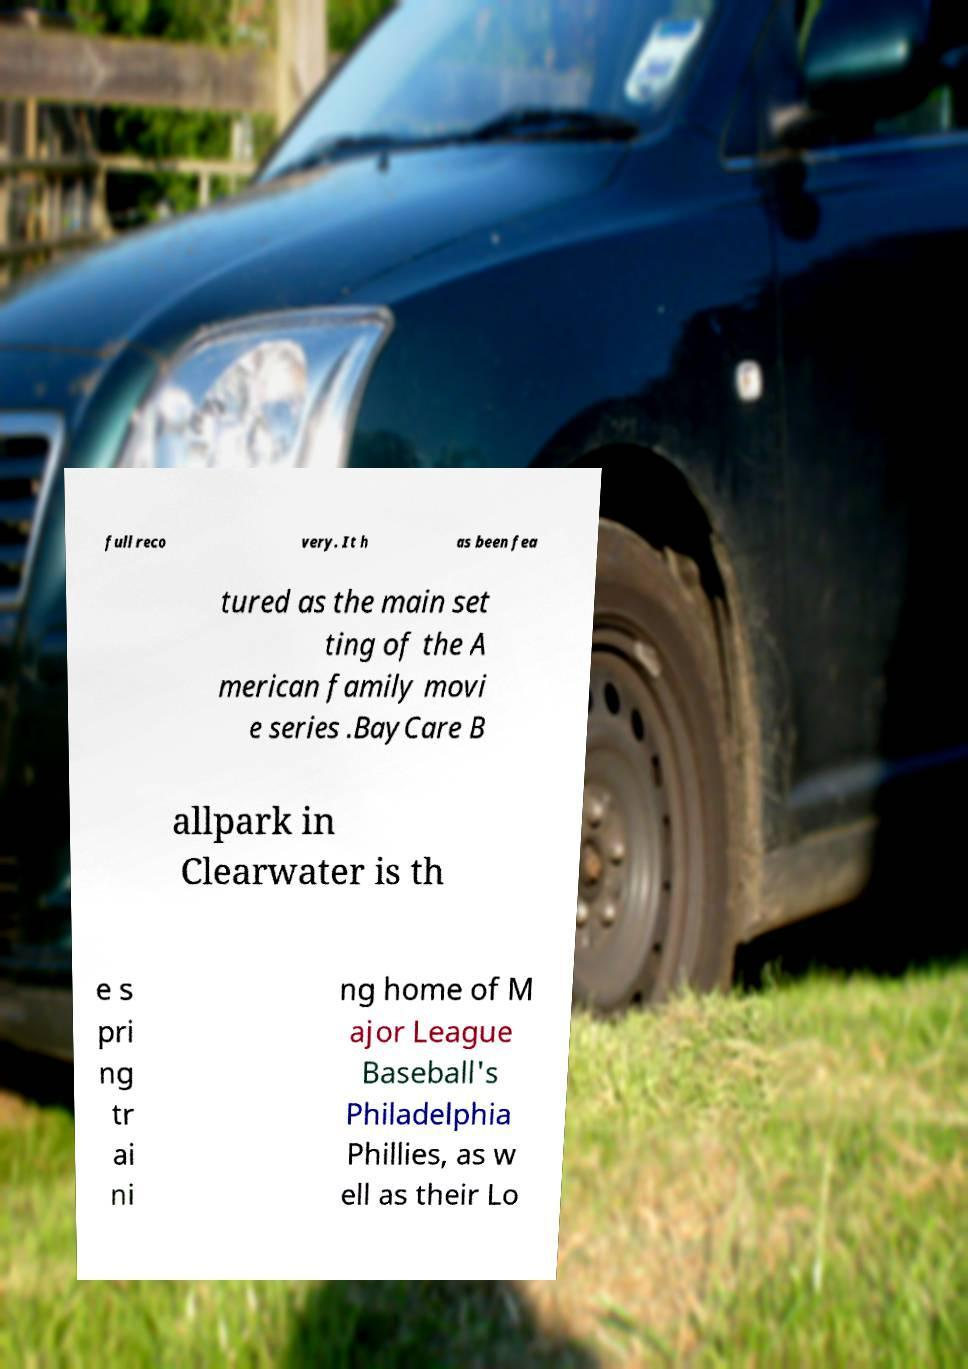Please identify and transcribe the text found in this image. full reco very. It h as been fea tured as the main set ting of the A merican family movi e series .BayCare B allpark in Clearwater is th e s pri ng tr ai ni ng home of M ajor League Baseball's Philadelphia Phillies, as w ell as their Lo 